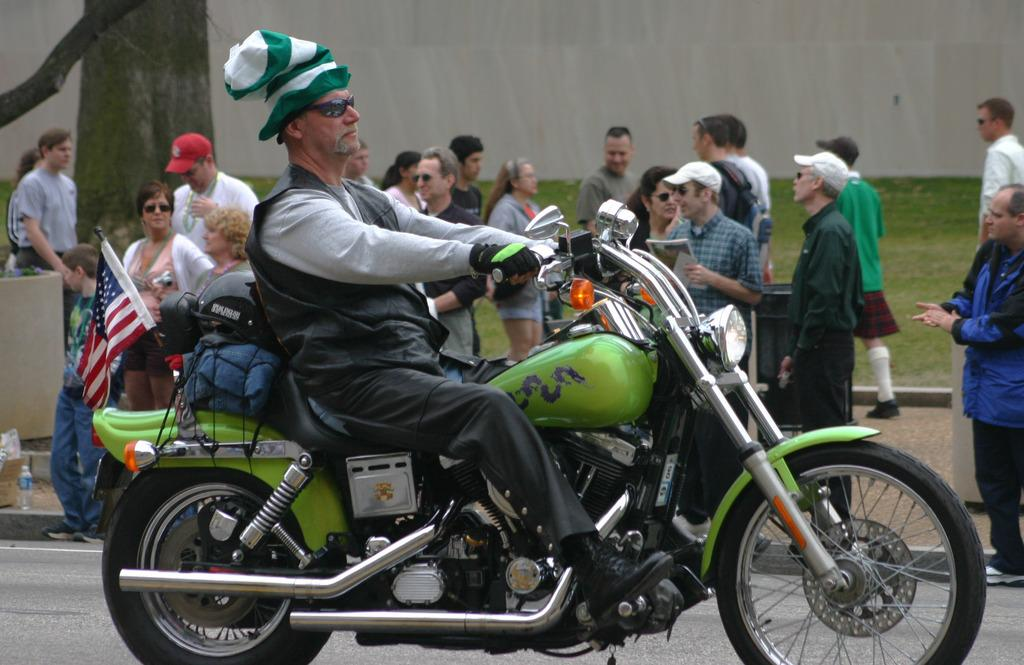Who is the main subject in the image? There is an old man in the image. What is the old man doing in the image? The old man is riding a motorbike. What can be seen behind the motorbike? There is a flag behind the motorbike. What is happening in the background of the image? There is a group of people standing in the background. How many dimes can be seen on the motorbike in the image? There are no dimes visible on the motorbike in the image. What historical event is being commemorated by the flag in the image? The image does not provide any information about the flag or its significance, so it is impossible to determine if it is commemorating a historical event. 